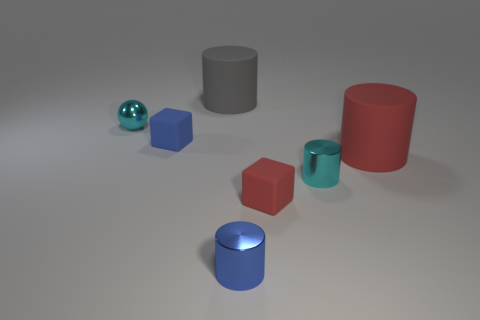Are there fewer red matte cylinders than tiny red rubber cylinders?
Give a very brief answer. No. How many cylinders are the same color as the metal ball?
Your answer should be very brief. 1. Do the sphere and the rubber thing that is to the right of the tiny red rubber thing have the same color?
Your answer should be compact. No. Is the number of blue shiny things greater than the number of brown balls?
Your answer should be very brief. Yes. What is the size of the gray object that is the same shape as the big red object?
Provide a short and direct response. Large. Is the small blue cylinder made of the same material as the cyan object that is behind the cyan metal cylinder?
Make the answer very short. Yes. What number of objects are either gray things or cyan objects?
Ensure brevity in your answer.  3. There is a sphere that is on the left side of the tiny red matte object; is it the same size as the rubber cylinder that is to the left of the small red cube?
Make the answer very short. No. What number of cubes are blue metallic things or cyan shiny things?
Make the answer very short. 0. Are any shiny balls visible?
Keep it short and to the point. Yes. 